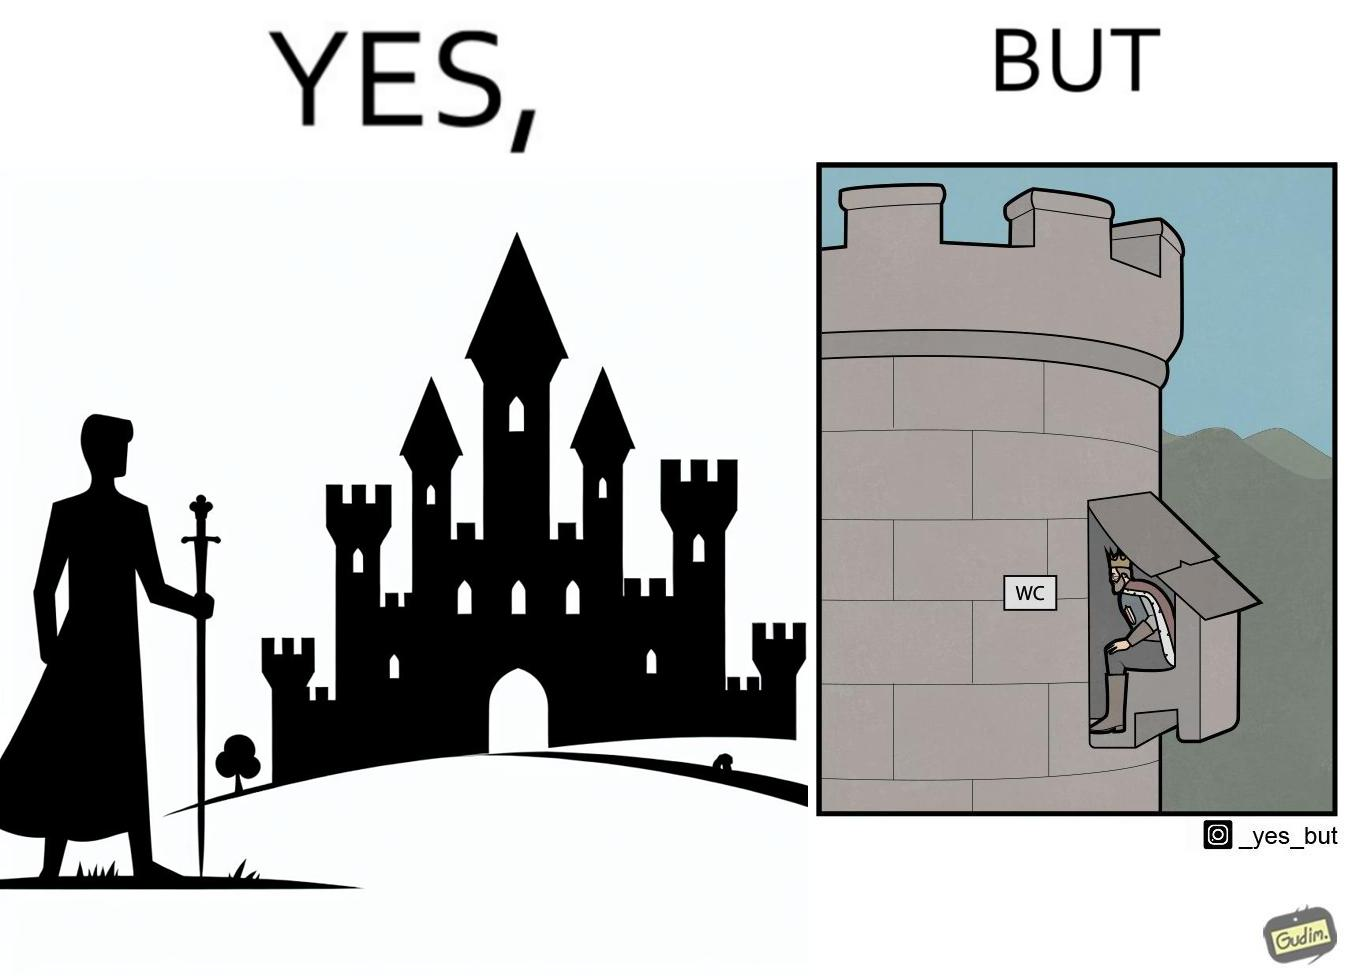What do you see in each half of this image? In the left part of the image: It is a mighty king in front of a castle In the right part of the image: It is a man using the toilet in a castle 